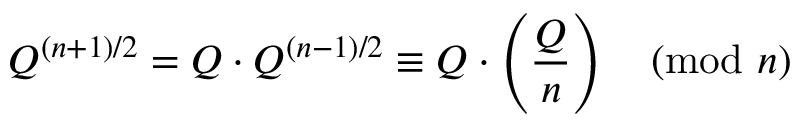<formula> <loc_0><loc_0><loc_500><loc_500>Q ^ { ( n + 1 ) / 2 } = Q \cdot Q ^ { ( n - 1 ) / 2 } \equiv Q \cdot \left ( { \frac { Q } { n } } \right ) { \pmod { n } }</formula> 